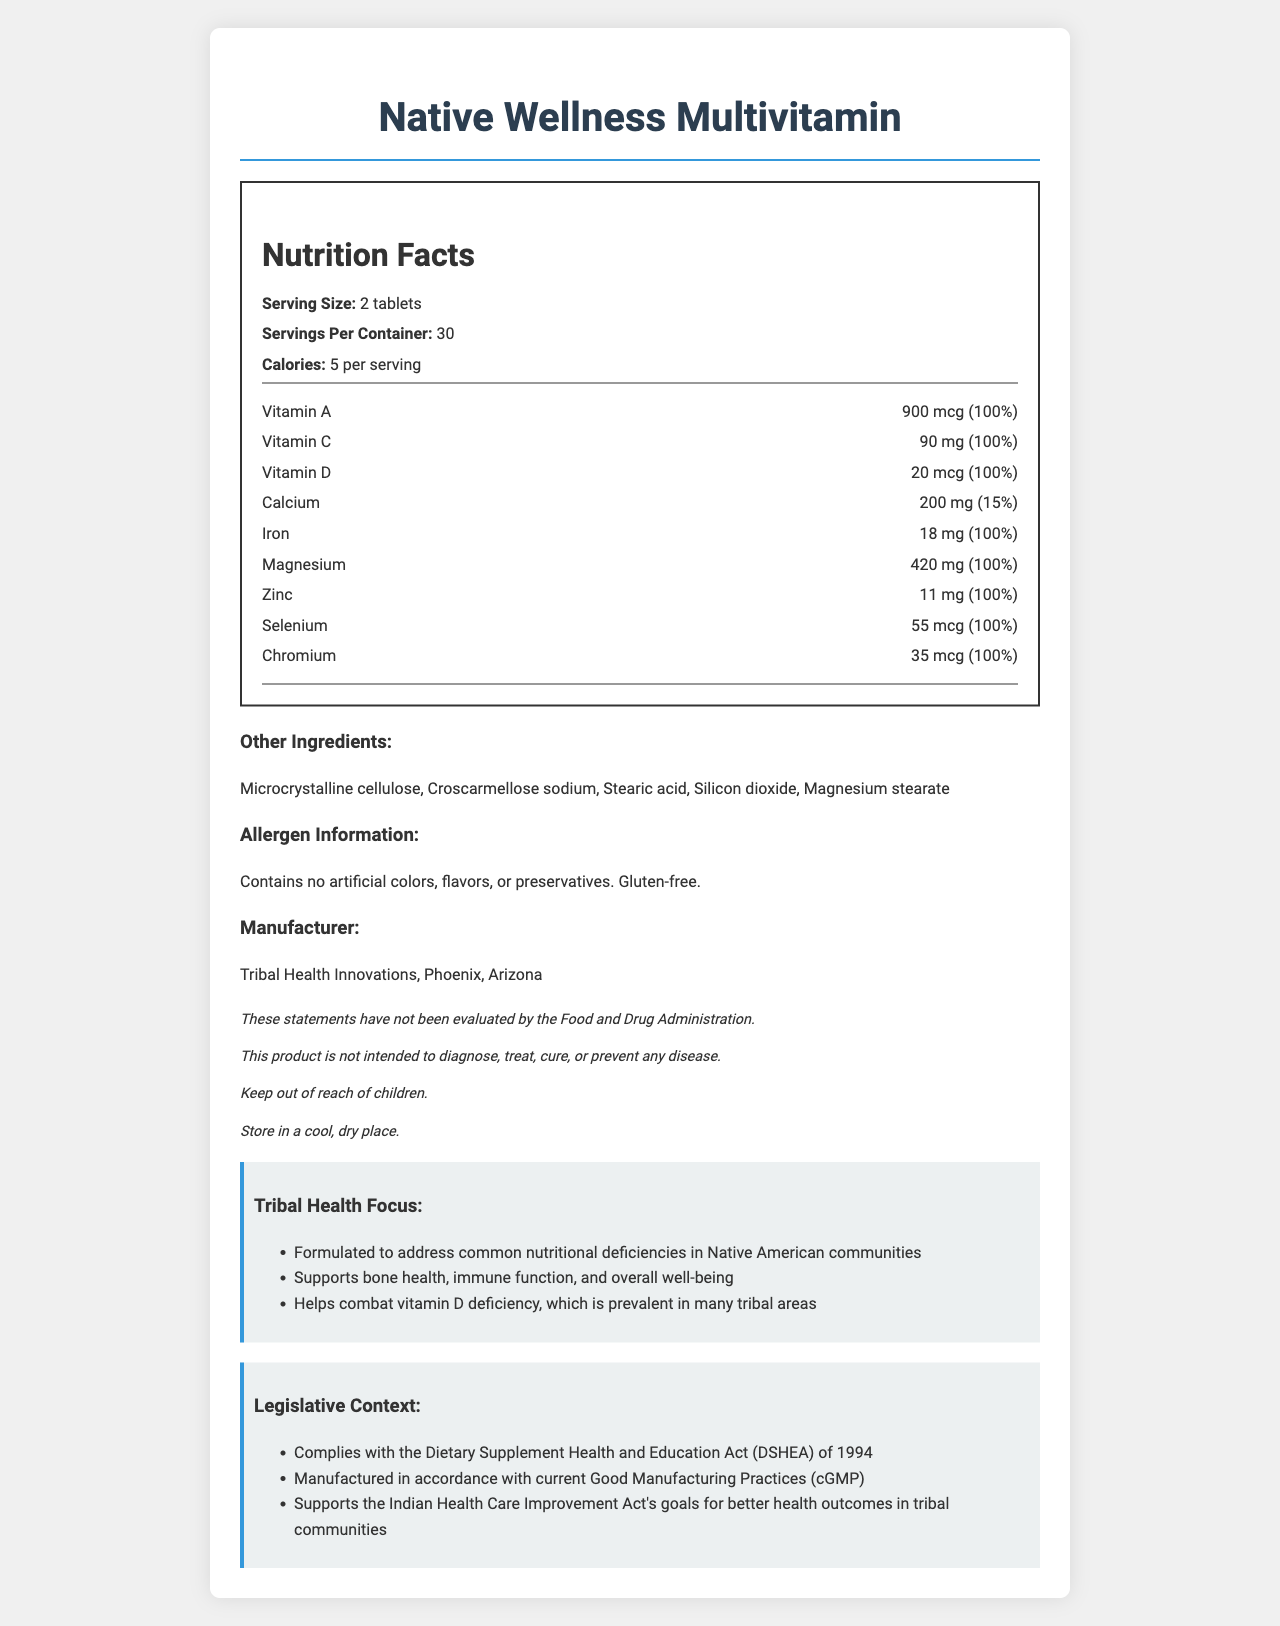what is the serving size? The document states that the serving size is "2 tablets" under the Nutrition Facts section.
Answer: 2 tablets how many calories are in each serving? According to the Nutrition Facts section, each serving contains 5 calories.
Answer: 5 calories who is the manufacturer? The document lists the manufacturer as "Tribal Health Innovations" under the Manufacturer section.
Answer: Tribal Health Innovations where is the manufacturer located? The document states that the manufacturer's location is "Phoenix, Arizona" under the Manufacturer section.
Answer: Phoenix, Arizona what ingredients are listed under "Other Ingredients"? The Other Ingredients section lists these five ingredients.
Answer: Microcrystalline cellulose, Croscarmellose sodium, Stearic acid, Silicon dioxide, Magnesium stearate what percentage of daily value of Iron does one serving provide? The Nutrition Facts section lists Iron as providing 100% of the daily value per serving.
Answer: 100% does the product contain gluten? The allergen information states "Gluten-free."
Answer: No what is the main purpose of the product based on the tribal health focus? The Tribal Health Focus section mentions that it is formulated to address common nutritional deficiencies in Native American communities.
Answer: Addressing common nutritional deficiencies in Native American communities what legislative act does this product comply with? **A. FDA Modernization Act of 1997 B. Dietary Supplement Health and Education Act (DSHEA) of 1994 C. Indian Health Care Improvement Act of 1976 D. All of the above** The document states that the product complies with "Dietary Supplement Health and Education Act (DSHEA) of 1994."
Answer: B which vitamins are present in this supplement? **I. Vitamin A II. Vitamin C III. Vitamin D IV. Vitamin E**  **A. I and II  B. I, II, and III  C. I, III, and IV  D. I, II, III, and IV** The Nutrition Facts list Vitamin A, Vitamin C, and Vitamin D, but not Vitamin E.
Answer: B Is this product intended to diagnose, treat, cure, or prevent any disease? The disclaimers section states that "This product is not intended to diagnose, treat, cure, or prevent any disease."
Answer: No What is the daily value percentage of Vitamin D in each serving? According to the Nutrition Facts section, each serving provides 100% of the daily value of Vitamin D.
Answer: 100% list some common health issues this multivitamin targets. The Tribal Health Focus section lists these specific health aspects.
Answer: Bone health, immune function, overall well-being, vitamin D deficiency summarize the document. The document provides detailed information about the Native Wellness Multivitamin, including its nutritional components, intended health benefits for tribal communities, manufacturer details, and compliance with legislative acts aimed at improving health outcomes. It also includes disclaimers typical for dietary supplements.
Answer: Native Wellness Multivitamin is a dietary supplement designed to address the nutritional deficiencies common in Native American communities. It contains essential vitamins and minerals like Vitamin A, C, D, and Iron. Each serving size is 2 tablets, providing 5 calories, and comes with a month's supply per container. The product is manufactured by Tribal Health Innovations in Phoenix, Arizona, and complies with several legislative acts aimed at improving health outcomes in tribal communities. It is gluten-free and contains no artificial colors, flavors, or preservatives. how does the multivitamin support overall well-being? The Tribal Health Focus section states that the supplement supports overall well-being by providing essential vitamins and minerals.
Answer: Through essential nutrients like vitamins and minerals is there an artificial color in the product? The allergen information specifies that the product contains no artificial colors.
Answer: No what is the daily value percentage for Calcium? The Nutrition Facts section shows that each serving provides 15% of the daily value for Calcium.
Answer: 15% can we determine the tablet dimensions from the document? The document does not provide any information about the physical dimensions of the tablets.
Answer: Cannot be determined why is it important that the product is manufactured according to cGMP? The Legislative Context mentions compliance with current Good Manufacturing Practices (cGMP), which ensures the product's quality and safety.
Answer: Ensures product quality and safety 